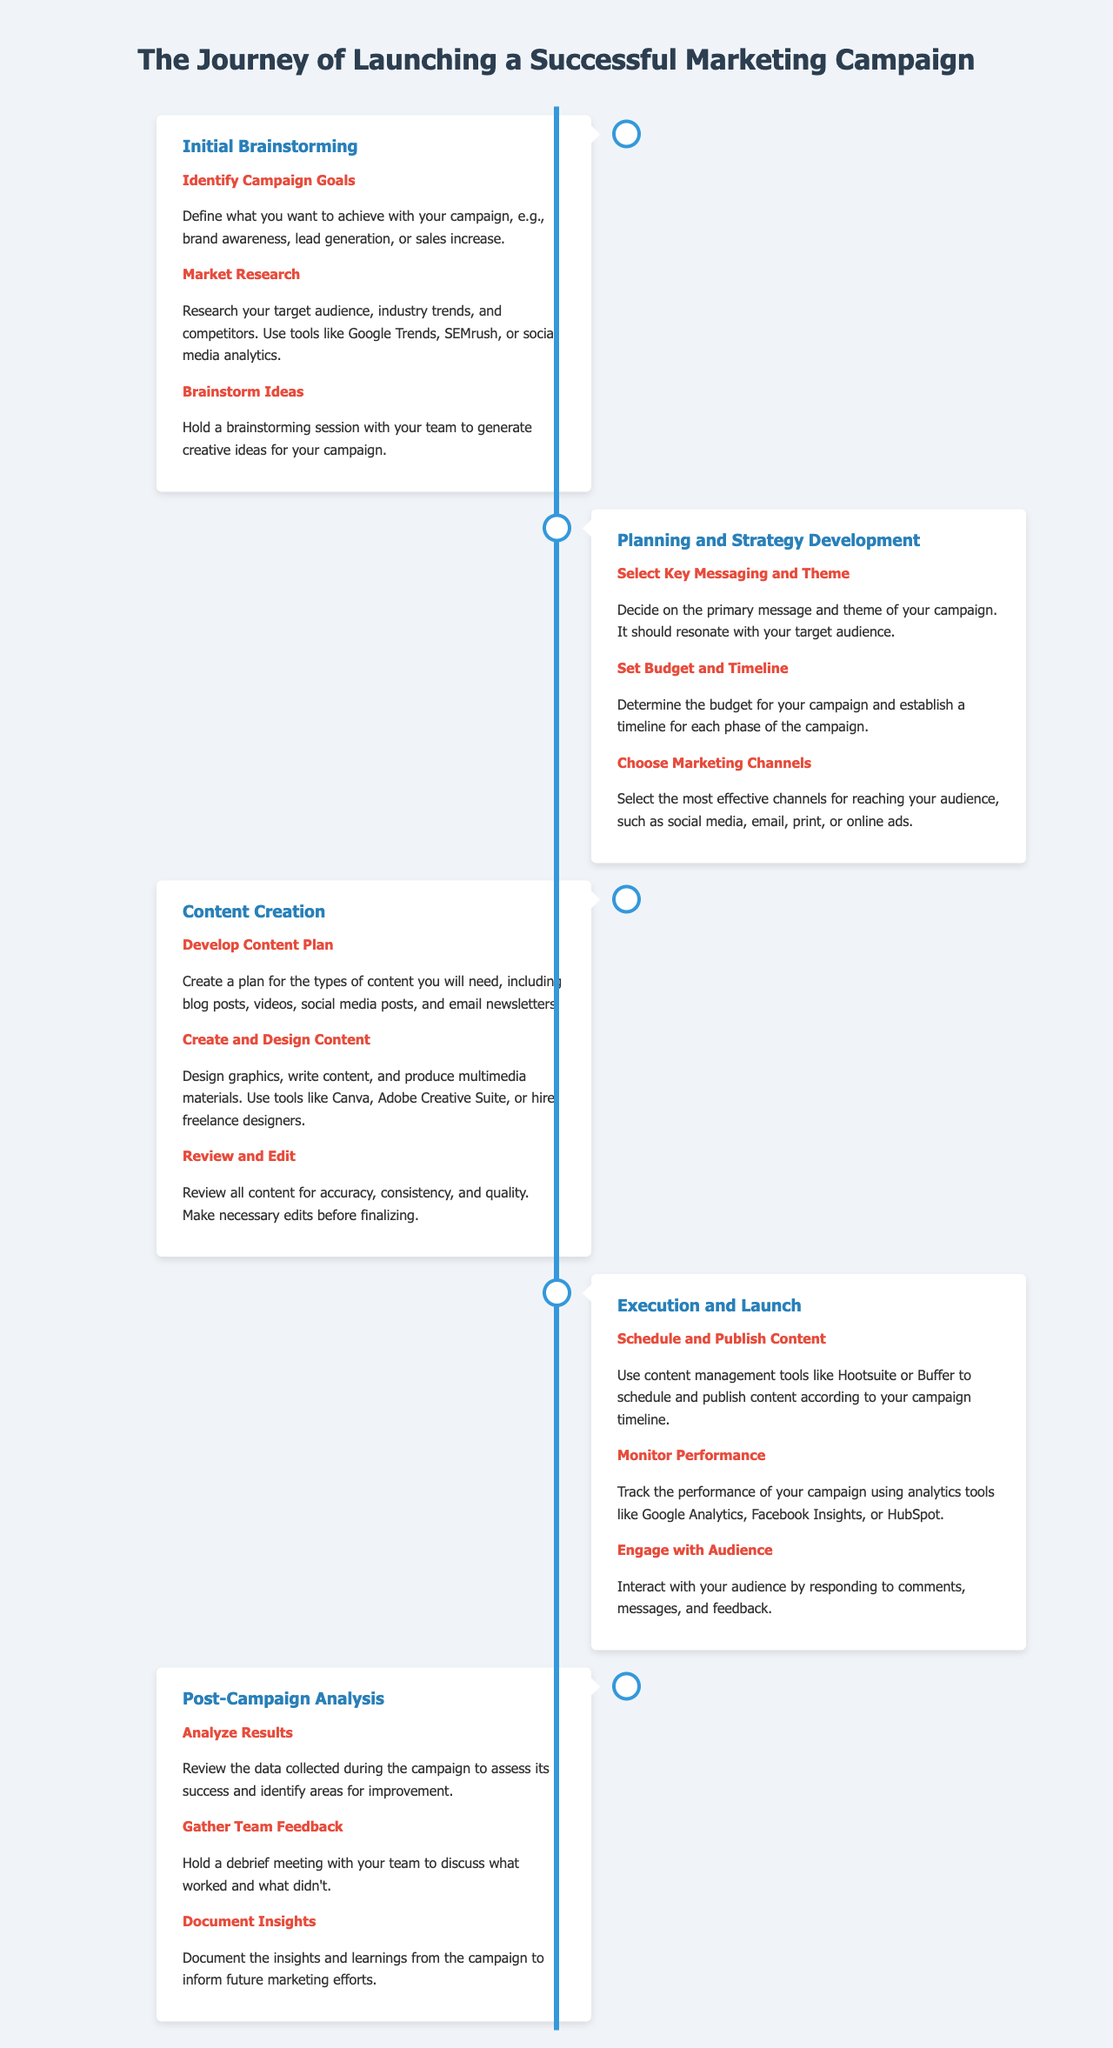What is the first phase of the marketing campaign journey? The first phase is stated at the beginning of the timeline as "Initial Brainstorming."
Answer: Initial Brainstorming What is one of the key steps under "Content Creation"? The document lists multiple steps under this phase, one of which is "Create and Design Content."
Answer: Create and Design Content How many steps are there in the "Execution and Launch" phase? By reviewing the document, there are three distinct steps listed under this phase.
Answer: 3 What does the "Planning and Strategy Development" phase focus on regarding the budget? One of the key steps mentioned is "Set Budget and Timeline."
Answer: Set Budget and Timeline What should be done during the "Post-Campaign Analysis"? The document recommends reviewing results, including "Analyze Results."
Answer: Analyze Results Which tools can be used to monitor campaign performance? The document references analytic tools including Google Analytics and Facebook Insights.
Answer: Google Analytics, Facebook Insights What is the last phase of the marketing campaign journey? The last phase is listed in the timeline and is called "Post-Campaign Analysis."
Answer: Post-Campaign Analysis Which phase includes gathering team feedback? The phase that includes this step is "Post-Campaign Analysis."
Answer: Post-Campaign Analysis What is the main focus of the initial brainstorming phase? The primary aim is to identify goals for the campaign, such as brand awareness or lead generation.
Answer: Identify Campaign Goals 